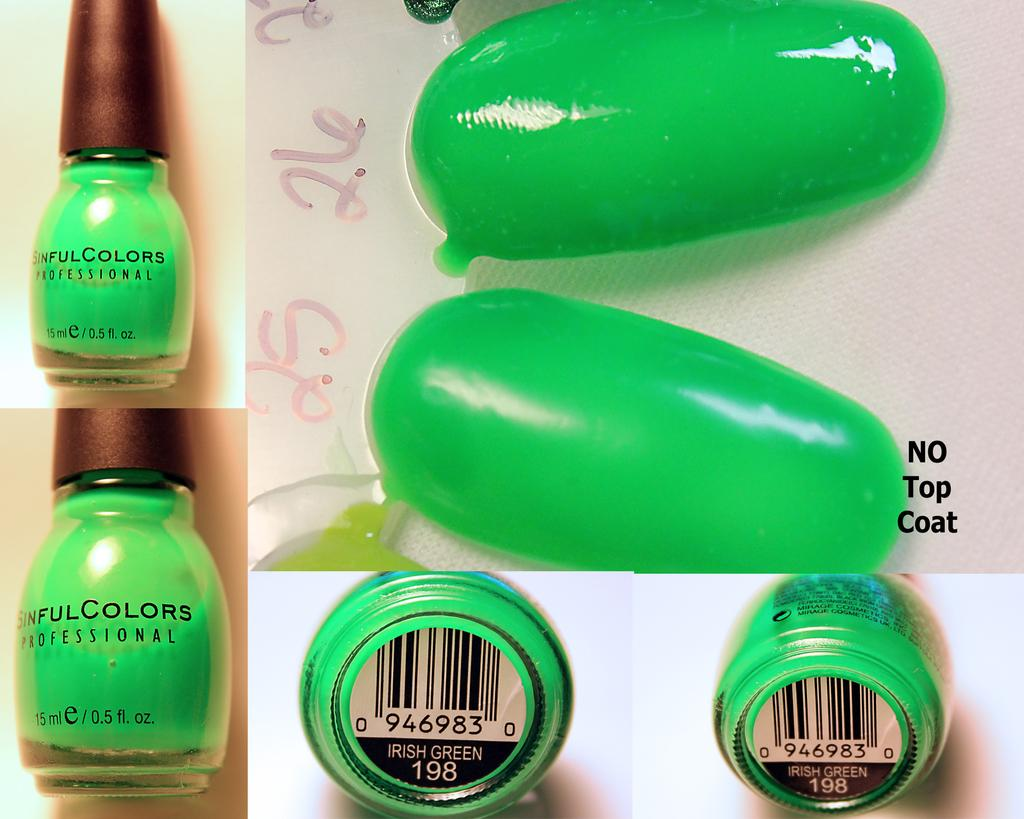<image>
Offer a succinct explanation of the picture presented. A bright green bottle of nail polish called Sinful Colors. 